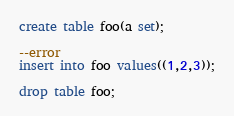<code> <loc_0><loc_0><loc_500><loc_500><_SQL_>create table foo(a set);

--error
insert into foo values((1,2,3));

drop table foo;
</code> 